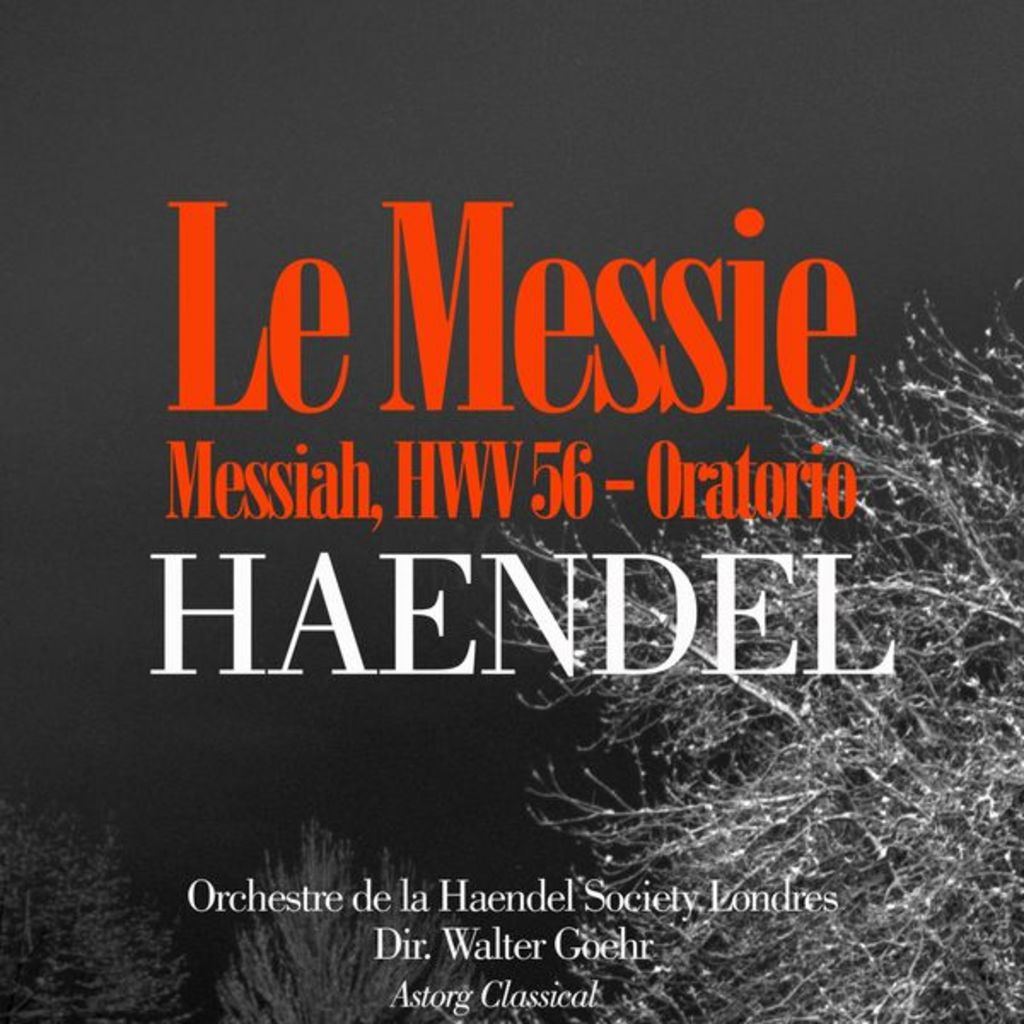Provide a one-sentence caption for the provided image. The image is a promotional poster for 'Le Messie Messiah, HWV 56 - Oratorio' by Handel, featuring a performance by the Orchestre de la Haendel Society under the direction of Walter Goehr, published by Astorg Classical. 